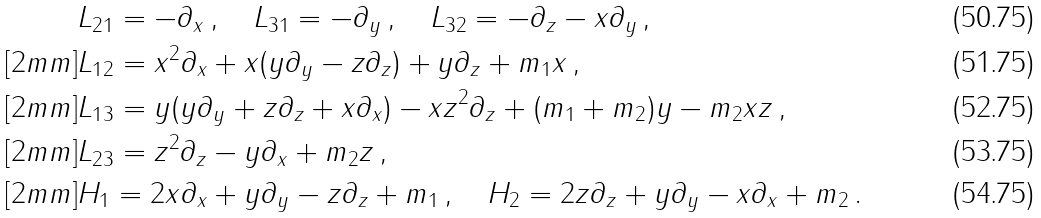<formula> <loc_0><loc_0><loc_500><loc_500>& L _ { 2 1 } = - \partial _ { x } \, , \quad L _ { 3 1 } = - \partial _ { y } \, , \quad L _ { 3 2 } = - \partial _ { z } - x \partial _ { y } \, , \\ [ 2 m m ] & L _ { 1 2 } = x ^ { 2 } \partial _ { x } + x ( y \partial _ { y } - z \partial _ { z } ) + y \partial _ { z } + m _ { 1 } x \, , \\ [ 2 m m ] & L _ { 1 3 } = y ( y \partial _ { y } + z \partial _ { z } + x \partial _ { x } ) - x z ^ { 2 } \partial _ { z } + ( m _ { 1 } + m _ { 2 } ) y - m _ { 2 } x z \, , \\ [ 2 m m ] & L _ { 2 3 } = z ^ { 2 } \partial _ { z } - y \partial _ { x } + m _ { 2 } z \, , \\ [ 2 m m ] & H _ { 1 } = 2 x \partial _ { x } + y \partial _ { y } - z \partial _ { z } + m _ { 1 } \, , \quad H _ { 2 } = 2 z \partial _ { z } + y \partial _ { y } - x \partial _ { x } + m _ { 2 } \, .</formula> 